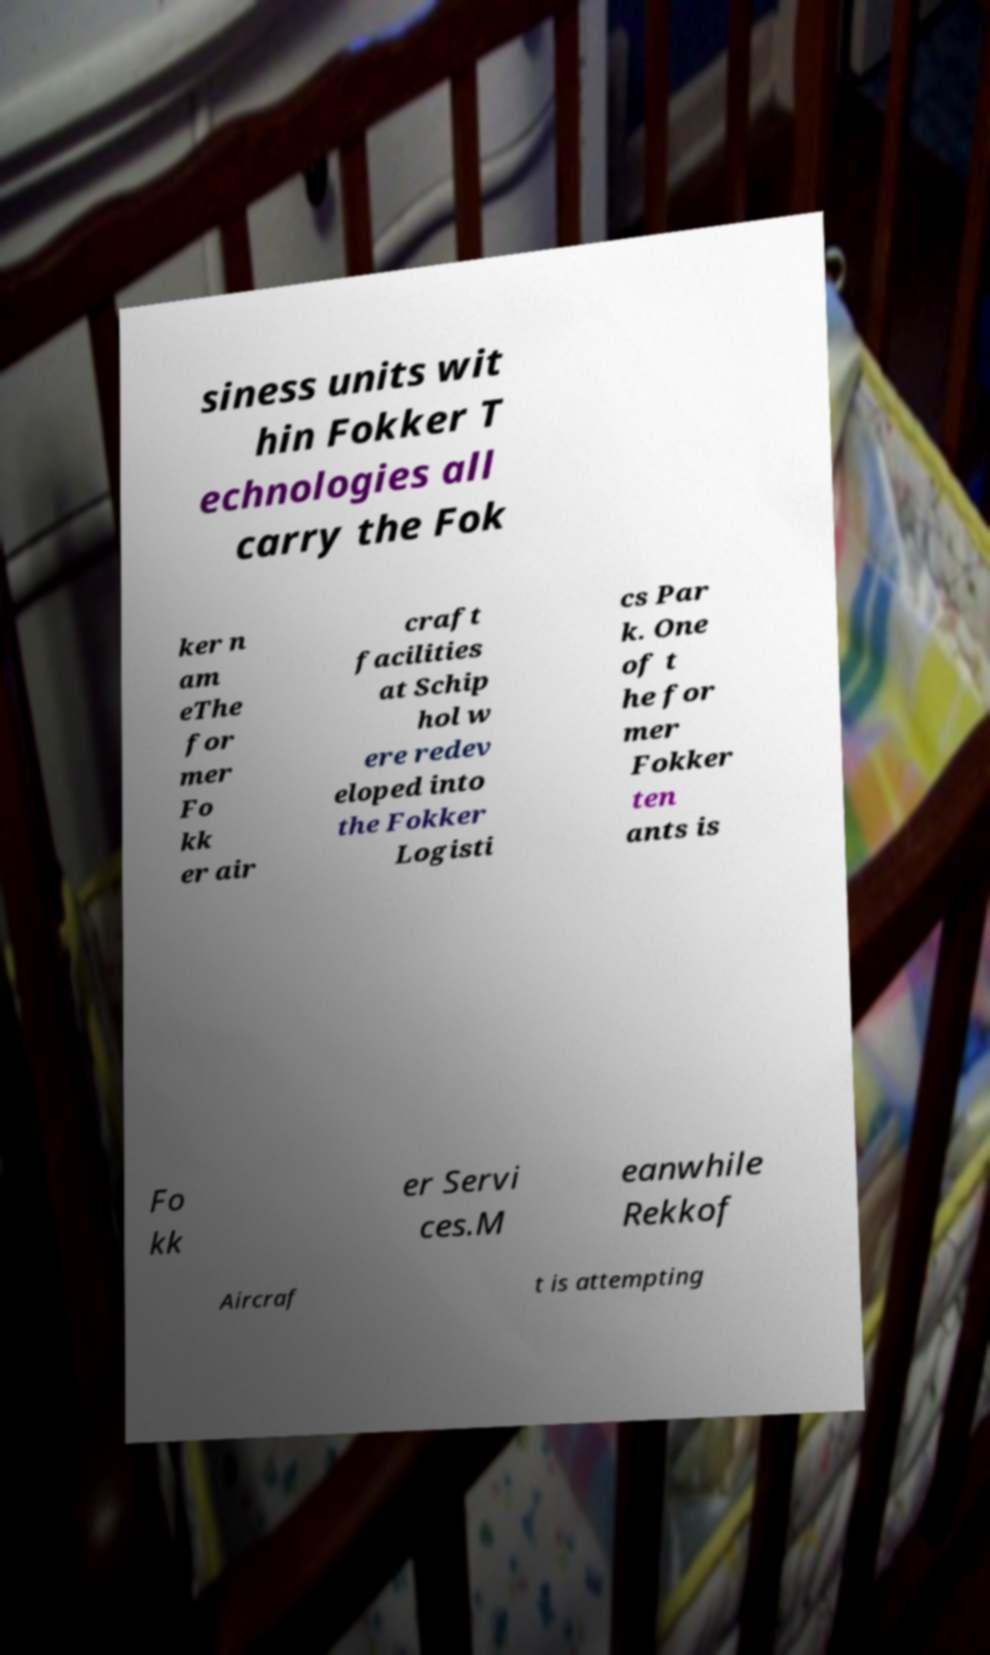Can you read and provide the text displayed in the image?This photo seems to have some interesting text. Can you extract and type it out for me? siness units wit hin Fokker T echnologies all carry the Fok ker n am eThe for mer Fo kk er air craft facilities at Schip hol w ere redev eloped into the Fokker Logisti cs Par k. One of t he for mer Fokker ten ants is Fo kk er Servi ces.M eanwhile Rekkof Aircraf t is attempting 